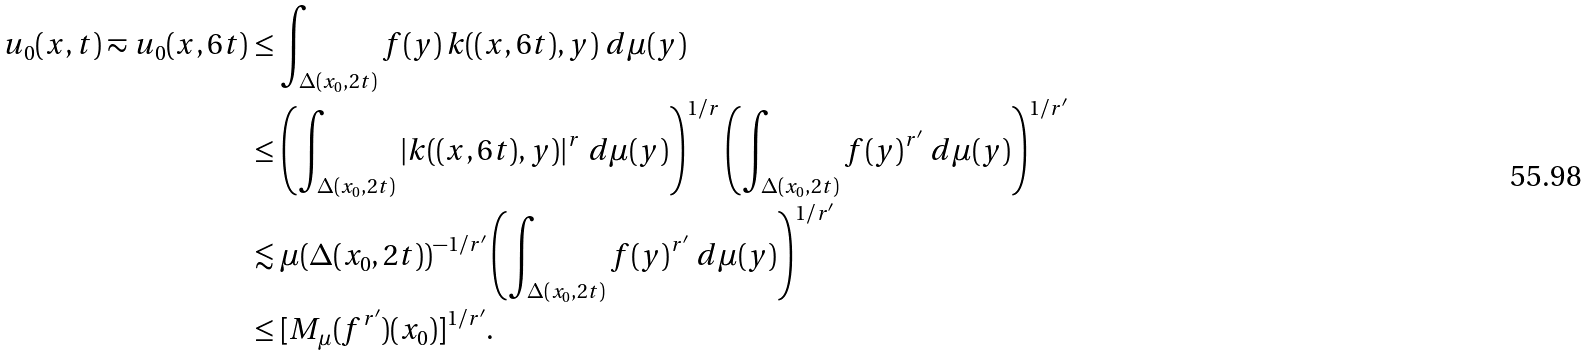<formula> <loc_0><loc_0><loc_500><loc_500>u _ { 0 } ( x , t ) \eqsim u _ { 0 } ( x , 6 t ) & \leq \int _ { \Delta ( x _ { 0 } , 2 t ) } f ( y ) \, k ( ( x , 6 t ) , y ) \ d \mu ( y ) \\ & \leq \left ( \int _ { \Delta ( x _ { 0 } , 2 t ) } | k ( ( x , 6 t ) , y ) | ^ { r } \ d \mu ( y ) \right ) ^ { 1 / r } \left ( \int _ { \Delta ( x _ { 0 } , 2 t ) } f ( y ) ^ { r ^ { \prime } } \ d \mu ( y ) \right ) ^ { 1 / r ^ { \prime } } \\ & \lesssim \mu ( \Delta ( x _ { 0 } , 2 t ) ) ^ { - 1 / r ^ { \prime } } \left ( \int _ { \Delta ( x _ { 0 } , 2 t ) } f ( y ) ^ { r ^ { \prime } } \ d \mu ( y ) \right ) ^ { 1 / r ^ { \prime } } \\ & \leq [ M _ { \mu } ( f ^ { r ^ { \prime } } ) ( x _ { 0 } ) ] ^ { 1 / r ^ { \prime } } .</formula> 